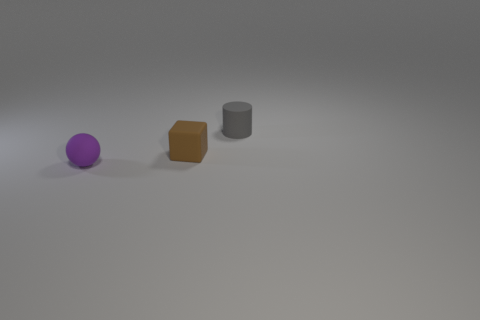Add 3 brown matte cubes. How many objects exist? 6 Subtract all cubes. How many objects are left? 2 Subtract all tiny purple rubber things. Subtract all tiny cylinders. How many objects are left? 1 Add 1 brown matte things. How many brown matte things are left? 2 Add 3 red matte objects. How many red matte objects exist? 3 Subtract 0 red cylinders. How many objects are left? 3 